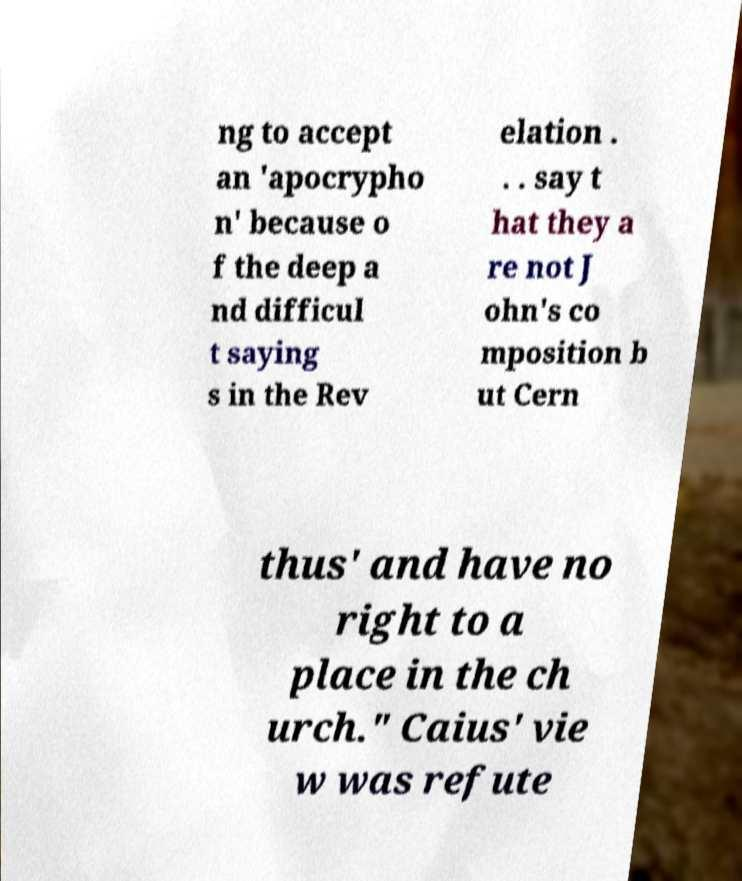What messages or text are displayed in this image? I need them in a readable, typed format. ng to accept an 'apocrypho n' because o f the deep a nd difficul t saying s in the Rev elation . . . say t hat they a re not J ohn's co mposition b ut Cern thus' and have no right to a place in the ch urch." Caius' vie w was refute 